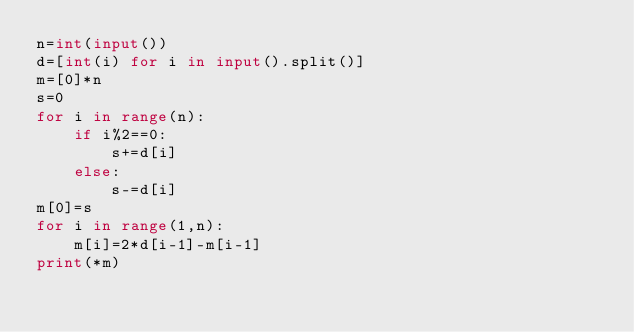Convert code to text. <code><loc_0><loc_0><loc_500><loc_500><_Python_>n=int(input())
d=[int(i) for i in input().split()]
m=[0]*n
s=0
for i in range(n):
    if i%2==0:
        s+=d[i]
    else:
        s-=d[i]
m[0]=s
for i in range(1,n):
    m[i]=2*d[i-1]-m[i-1]
print(*m)</code> 